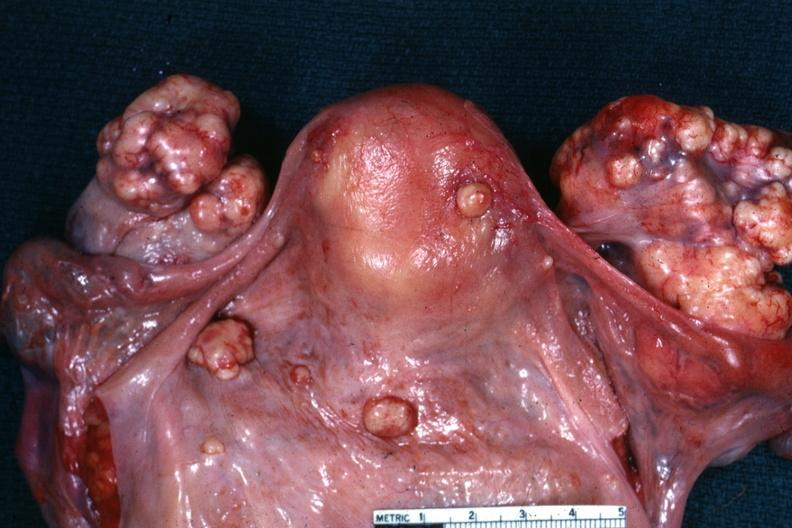what is present?
Answer the question using a single word or phrase. Female reproductive 